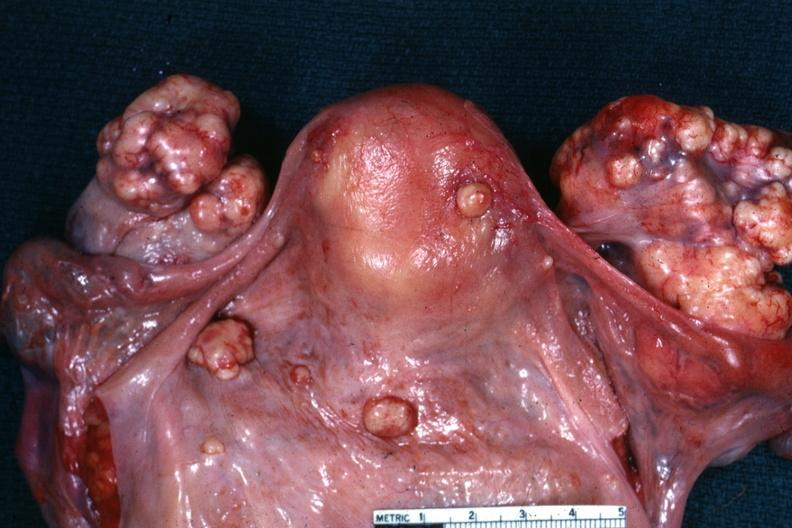what is present?
Answer the question using a single word or phrase. Female reproductive 